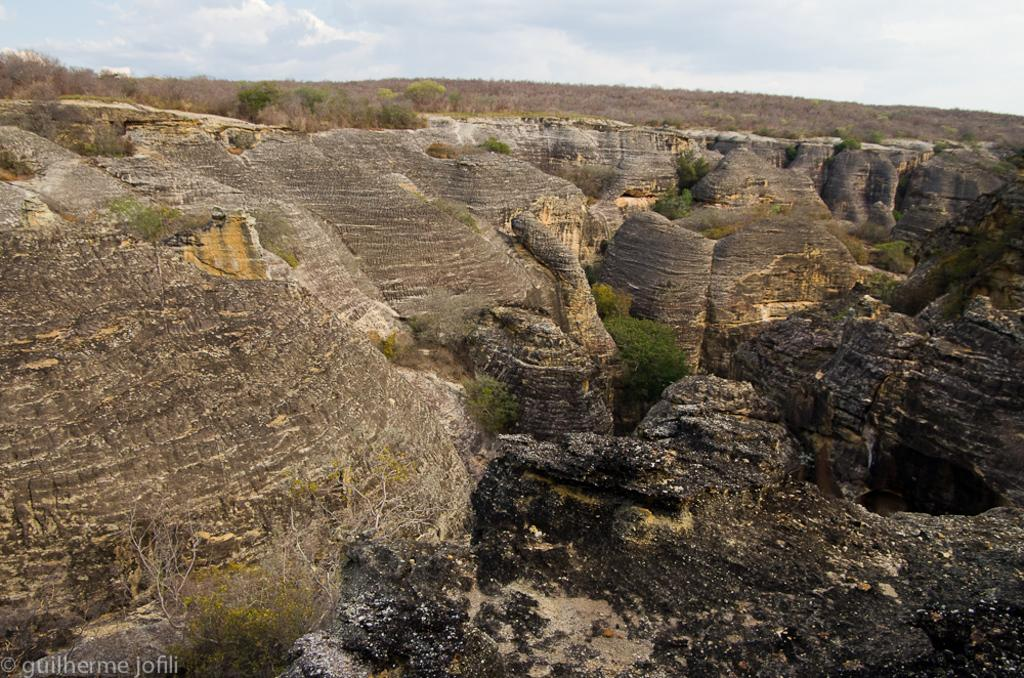What type of natural landscape is depicted in the image? The image features mountains, trees, and grass, indicating a natural landscape. What can be seen in the sky in the image? The sky is visible at the top of the image. What type of vegetation is present in the image? Trees and grass are present in the image. Where is the text located in the image? The text is in the left bottom corner of the image. How many corks are scattered on the grass in the image? There are no corks present in the image. What level of experience is required to climb the mountains in the image? The image does not provide information about the difficulty of climbing the mountains, nor does it indicate the experience level required. 